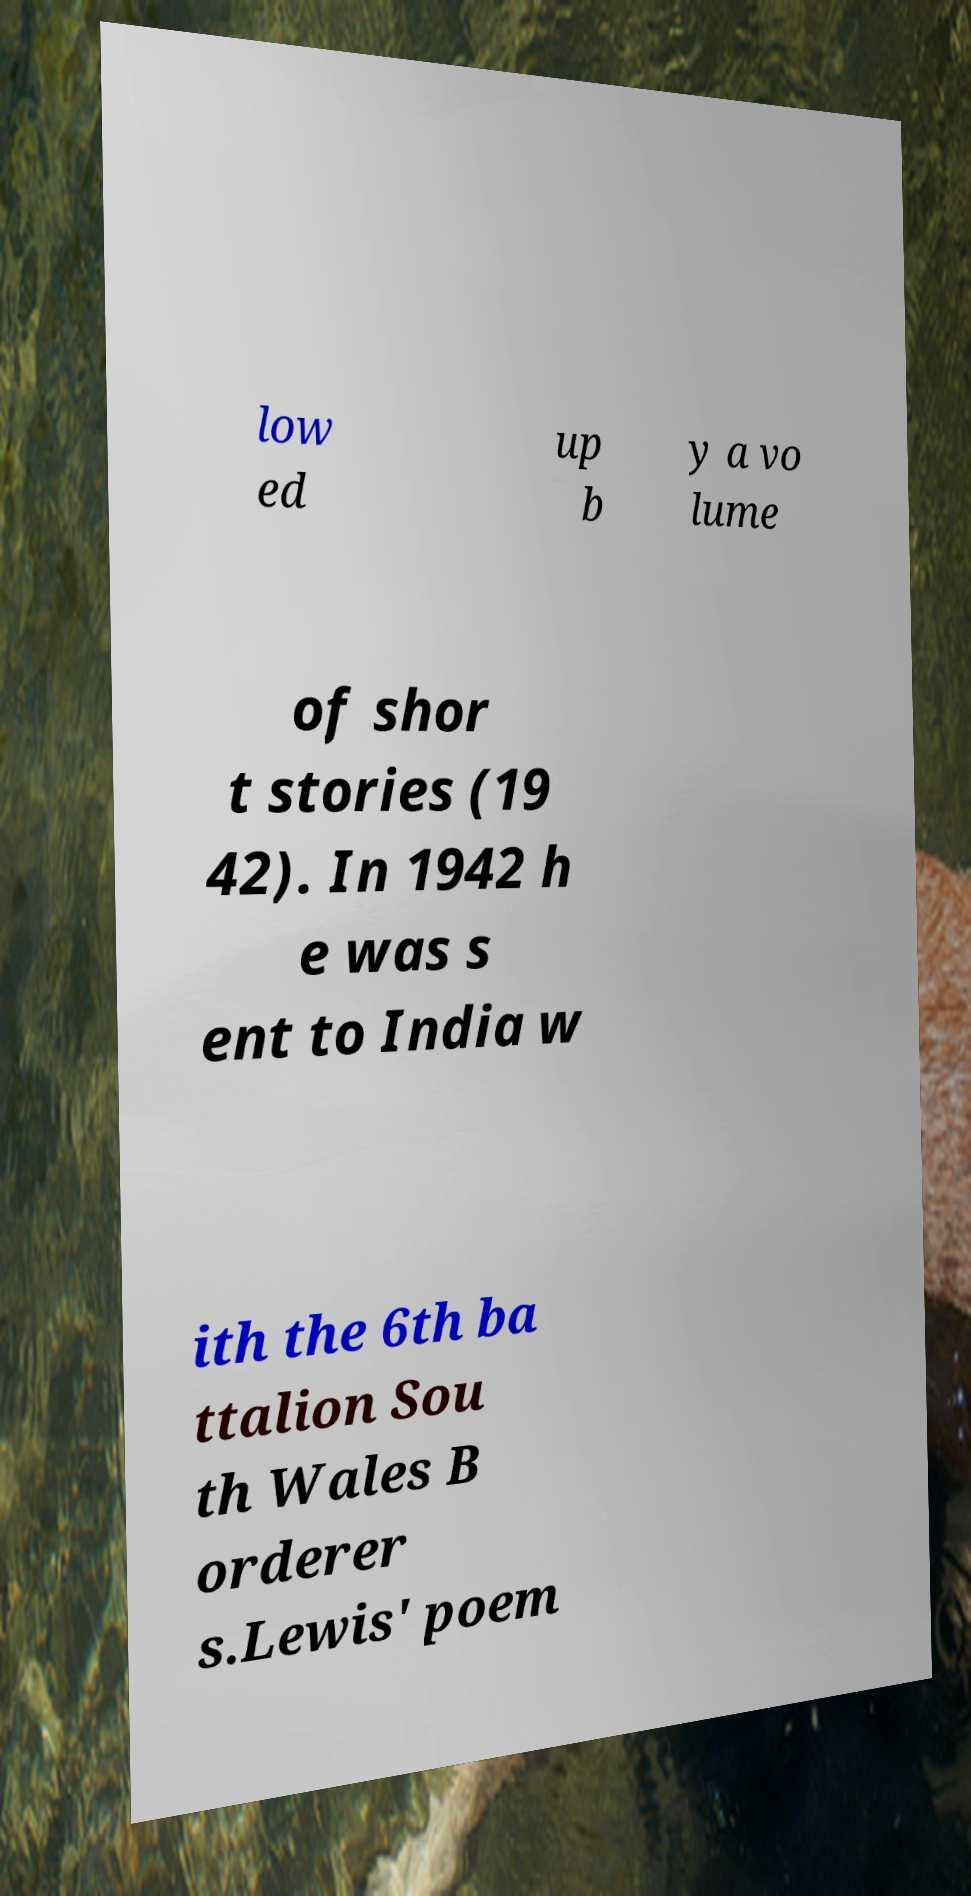Could you extract and type out the text from this image? low ed up b y a vo lume of shor t stories (19 42). In 1942 h e was s ent to India w ith the 6th ba ttalion Sou th Wales B orderer s.Lewis' poem 